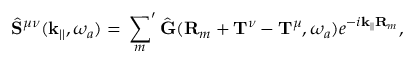<formula> <loc_0><loc_0><loc_500><loc_500>\hat { S } ^ { \mu \nu } ( k _ { | | } , \omega _ { a } ) = { ^ { \prime } } \sum _ { m } \hat { G } ( R _ { m } + T ^ { \nu } - T ^ { \mu } , \omega _ { a } ) e ^ { - i k _ { | | } R _ { m } } ,</formula> 